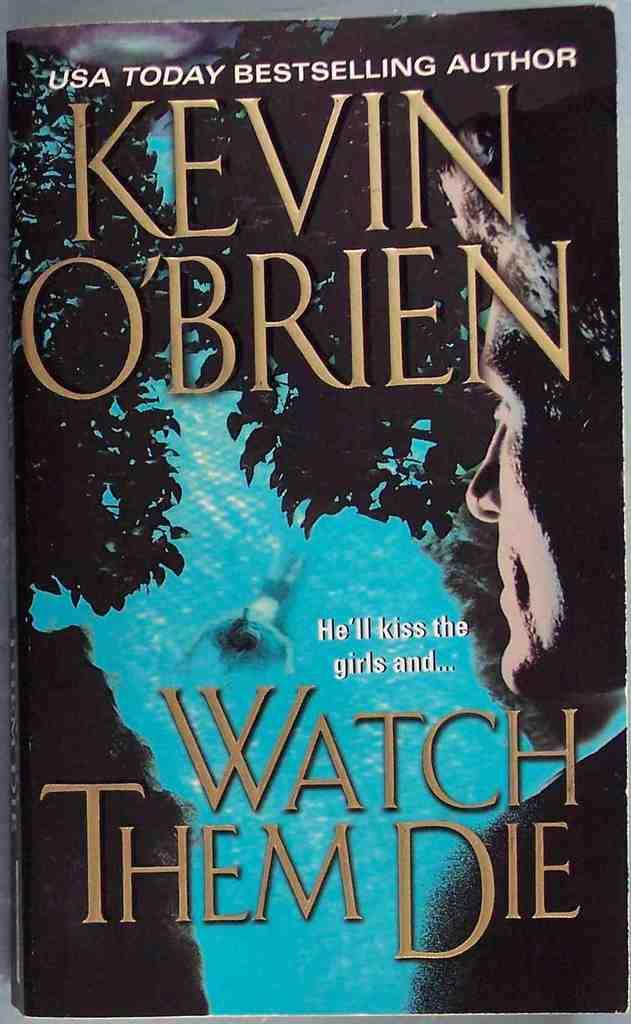<image>
Create a compact narrative representing the image presented. the cover of book Watch them Die by Kevin O'Brien 